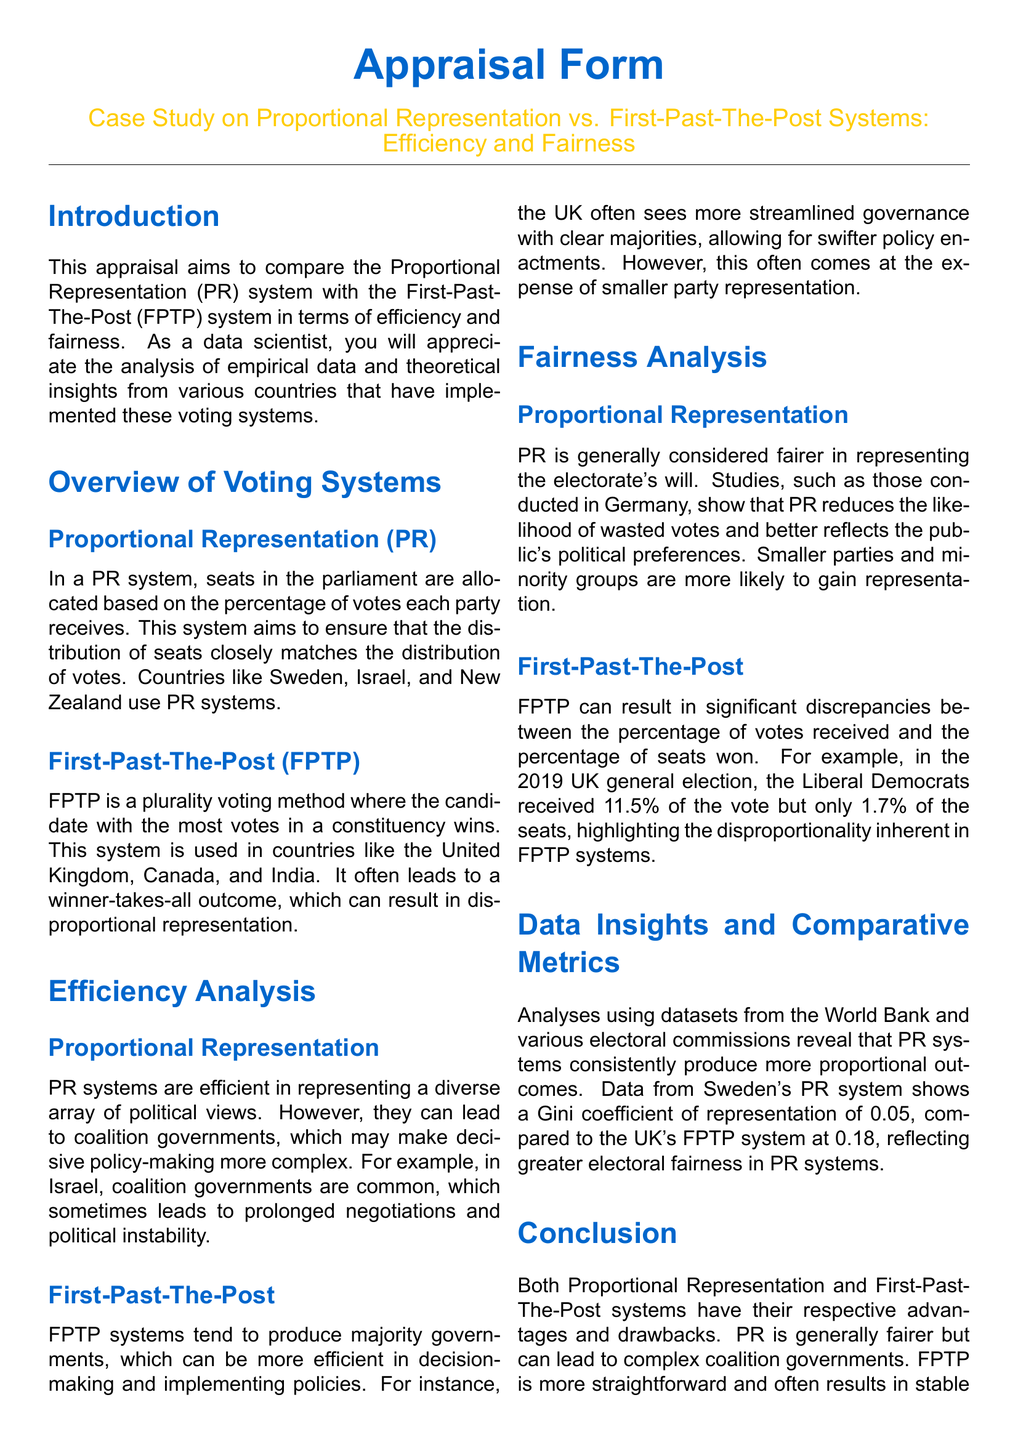What is the purpose of the appraisal? The appraisal aims to compare the Proportional Representation system with the First-Past-The-Post system in terms of efficiency and fairness.
Answer: Compare voting systems Which countries use the Proportional Representation system? The document lists Sweden, Israel, and New Zealand as countries that use PR systems.
Answer: Sweden, Israel, New Zealand What was the Gini coefficient of representation for Sweden's PR system? The document states that Sweden's PR system shows a Gini coefficient of representation of 0.05.
Answer: 0.05 What percentage of the vote did the Liberal Democrats receive in the 2019 UK general election? The document indicates that the Liberal Democrats received 11.5% of the vote.
Answer: 11.5% What is a noted drawback of the Proportional Representation system? The document mentions that PR can lead to coalition governments, complicating policy-making.
Answer: Coalition governments Which voting system is considered more straightforward for governance? The appraisal suggests that FPTP is more straightforward and often results in stable majority governments.
Answer: FPTP What is a common outcome of First-Past-The-Post systems? The document highlights that FPTP tends to produce majority governments.
Answer: Majority governments In which country is the likelihood of wasted votes reduced? The document states that PR systems, such as those studied in Germany, reduce the likelihood of wasted votes.
Answer: Germany What does the term "disproportionality" refer to in the context of FPTP? Disproportionality refers to significant discrepancies between the percentage of votes received and the percentage of seats won.
Answer: Discrepancies in votes and seats 